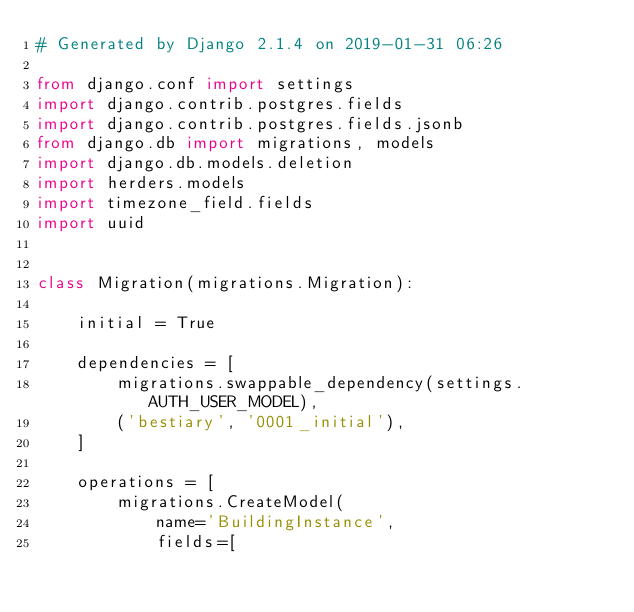<code> <loc_0><loc_0><loc_500><loc_500><_Python_># Generated by Django 2.1.4 on 2019-01-31 06:26

from django.conf import settings
import django.contrib.postgres.fields
import django.contrib.postgres.fields.jsonb
from django.db import migrations, models
import django.db.models.deletion
import herders.models
import timezone_field.fields
import uuid


class Migration(migrations.Migration):

    initial = True

    dependencies = [
        migrations.swappable_dependency(settings.AUTH_USER_MODEL),
        ('bestiary', '0001_initial'),
    ]

    operations = [
        migrations.CreateModel(
            name='BuildingInstance',
            fields=[</code> 